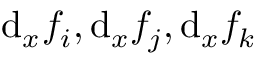<formula> <loc_0><loc_0><loc_500><loc_500>d _ { x } f _ { i } , d _ { x } f _ { j } , d _ { x } f _ { k }</formula> 